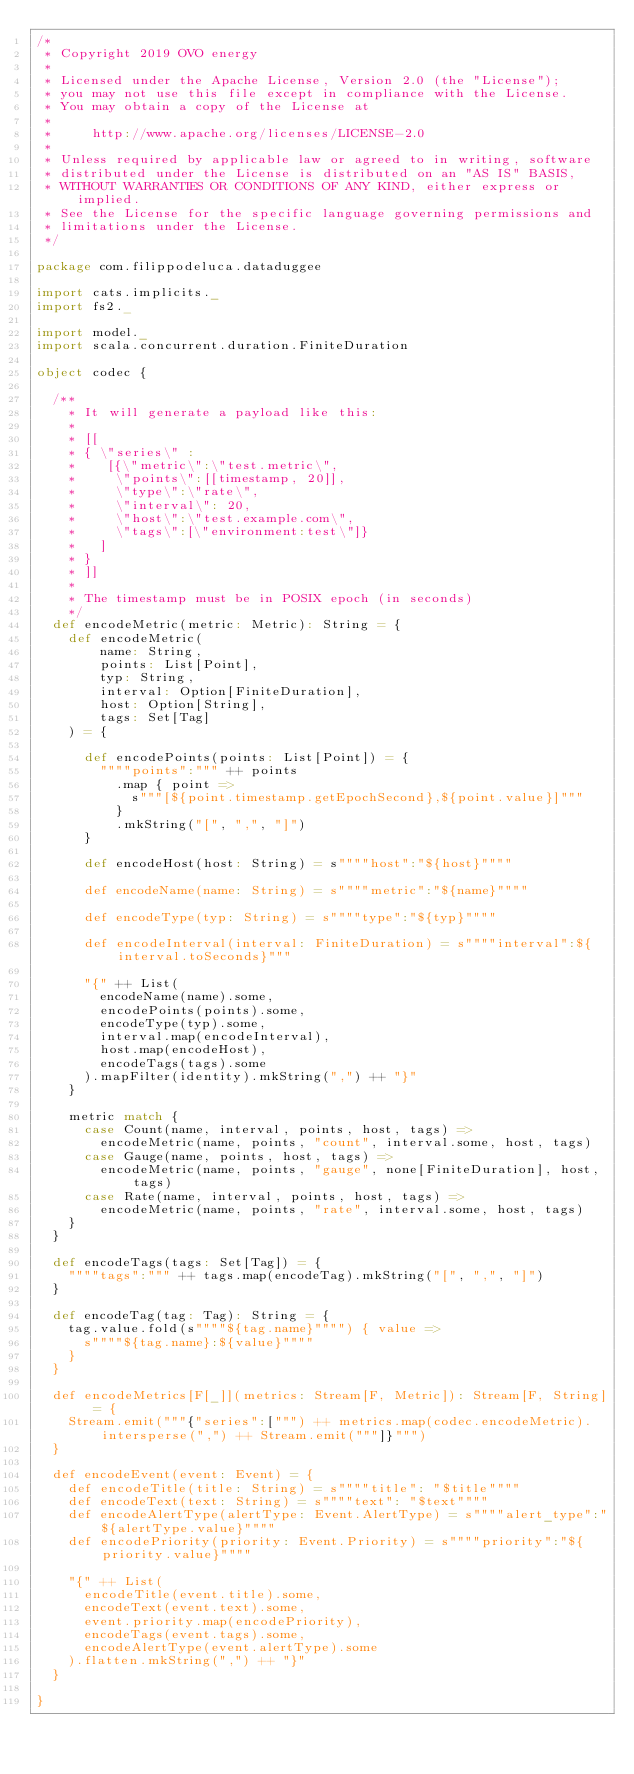Convert code to text. <code><loc_0><loc_0><loc_500><loc_500><_Scala_>/*
 * Copyright 2019 OVO energy
 *
 * Licensed under the Apache License, Version 2.0 (the "License");
 * you may not use this file except in compliance with the License.
 * You may obtain a copy of the License at
 *
 *     http://www.apache.org/licenses/LICENSE-2.0
 *
 * Unless required by applicable law or agreed to in writing, software
 * distributed under the License is distributed on an "AS IS" BASIS,
 * WITHOUT WARRANTIES OR CONDITIONS OF ANY KIND, either express or implied.
 * See the License for the specific language governing permissions and
 * limitations under the License.
 */

package com.filippodeluca.dataduggee

import cats.implicits._
import fs2._

import model._
import scala.concurrent.duration.FiniteDuration

object codec {

  /**
    * It will generate a payload like this:
    *
    * [[
    * { \"series\" :
    *    [{\"metric\":\"test.metric\",
    *     \"points\":[[timestamp, 20]],
    *     \"type\":\"rate\",
    *     \"interval\": 20,
    *     \"host\":\"test.example.com\",
    *     \"tags\":[\"environment:test\"]}
    *   ]
    * }
    * ]]
    *
    * The timestamp must be in POSIX epoch (in seconds)
    */
  def encodeMetric(metric: Metric): String = {
    def encodeMetric(
        name: String,
        points: List[Point],
        typ: String,
        interval: Option[FiniteDuration],
        host: Option[String],
        tags: Set[Tag]
    ) = {

      def encodePoints(points: List[Point]) = {
        """"points":""" ++ points
          .map { point =>
            s"""[${point.timestamp.getEpochSecond},${point.value}]"""
          }
          .mkString("[", ",", "]")
      }

      def encodeHost(host: String) = s""""host":"${host}""""

      def encodeName(name: String) = s""""metric":"${name}""""

      def encodeType(typ: String) = s""""type":"${typ}""""

      def encodeInterval(interval: FiniteDuration) = s""""interval":${interval.toSeconds}"""

      "{" ++ List(
        encodeName(name).some,
        encodePoints(points).some,
        encodeType(typ).some,
        interval.map(encodeInterval),
        host.map(encodeHost),
        encodeTags(tags).some
      ).mapFilter(identity).mkString(",") ++ "}"
    }

    metric match {
      case Count(name, interval, points, host, tags) =>
        encodeMetric(name, points, "count", interval.some, host, tags)
      case Gauge(name, points, host, tags) =>
        encodeMetric(name, points, "gauge", none[FiniteDuration], host, tags)
      case Rate(name, interval, points, host, tags) =>
        encodeMetric(name, points, "rate", interval.some, host, tags)
    }
  }

  def encodeTags(tags: Set[Tag]) = {
    """"tags":""" ++ tags.map(encodeTag).mkString("[", ",", "]")
  }

  def encodeTag(tag: Tag): String = {
    tag.value.fold(s""""${tag.name}"""") { value =>
      s""""${tag.name}:${value}""""
    }
  }

  def encodeMetrics[F[_]](metrics: Stream[F, Metric]): Stream[F, String] = {
    Stream.emit("""{"series":[""") ++ metrics.map(codec.encodeMetric).intersperse(",") ++ Stream.emit("""]}""")
  }

  def encodeEvent(event: Event) = {
    def encodeTitle(title: String) = s""""title": "$title""""
    def encodeText(text: String) = s""""text": "$text""""
    def encodeAlertType(alertType: Event.AlertType) = s""""alert_type":"${alertType.value}""""
    def encodePriority(priority: Event.Priority) = s""""priority":"${priority.value}""""

    "{" ++ List(
      encodeTitle(event.title).some,
      encodeText(event.text).some,
      event.priority.map(encodePriority),
      encodeTags(event.tags).some,
      encodeAlertType(event.alertType).some
    ).flatten.mkString(",") ++ "}"
  }

}
</code> 